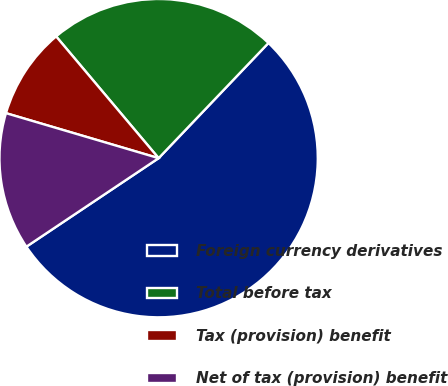Convert chart. <chart><loc_0><loc_0><loc_500><loc_500><pie_chart><fcel>Foreign currency derivatives<fcel>Total before tax<fcel>Tax (provision) benefit<fcel>Net of tax (provision) benefit<nl><fcel>53.49%<fcel>23.26%<fcel>9.3%<fcel>13.95%<nl></chart> 